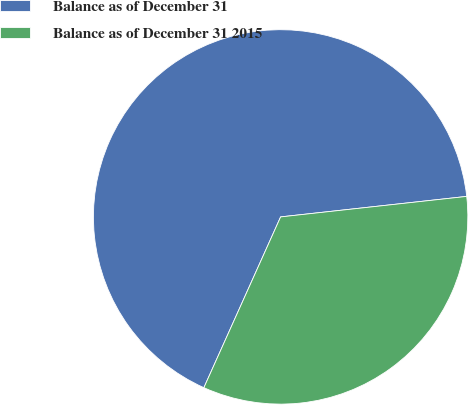Convert chart. <chart><loc_0><loc_0><loc_500><loc_500><pie_chart><fcel>Balance as of December 31<fcel>Balance as of December 31 2015<nl><fcel>66.53%<fcel>33.47%<nl></chart> 